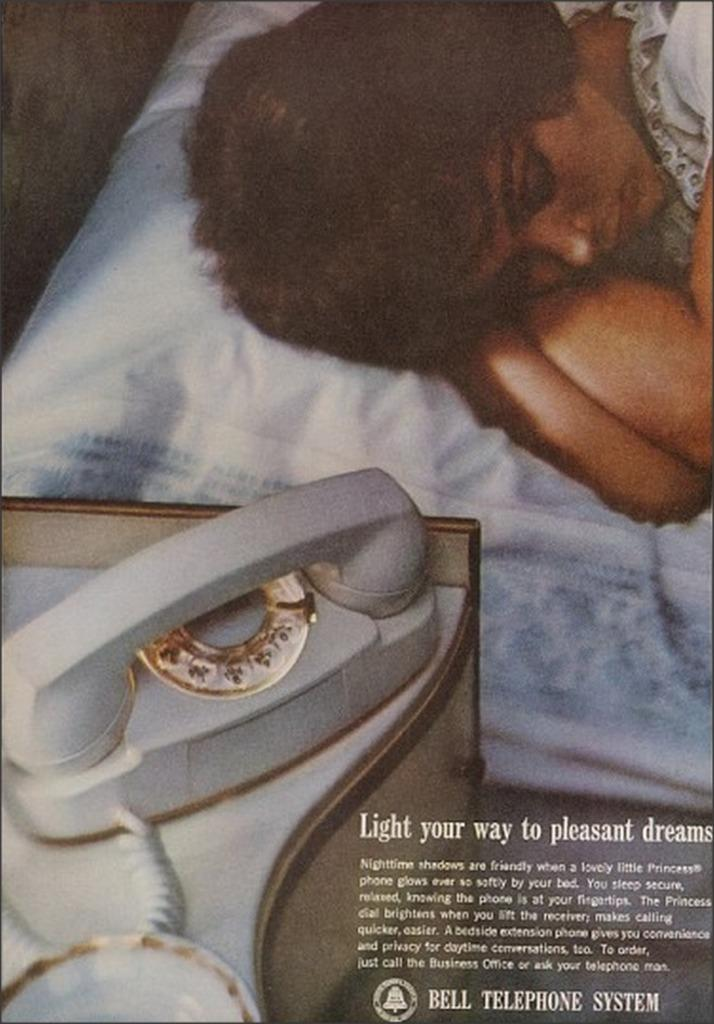What is featured on the poster in the image? There is a poster with text in the image. What is the person in the image doing? There is a person sleeping on a bed in the image. What piece of furniture is present in the image? There is a table in the image. What items are on the table in the image? There is a bowl and a phone on the table in the image. Can you tell me how many volcanoes are visible in the image? There are no volcanoes present in the image. What type of camera is being used by the person in the image? There is no camera visible in the image, as the person is sleeping on a bed. 